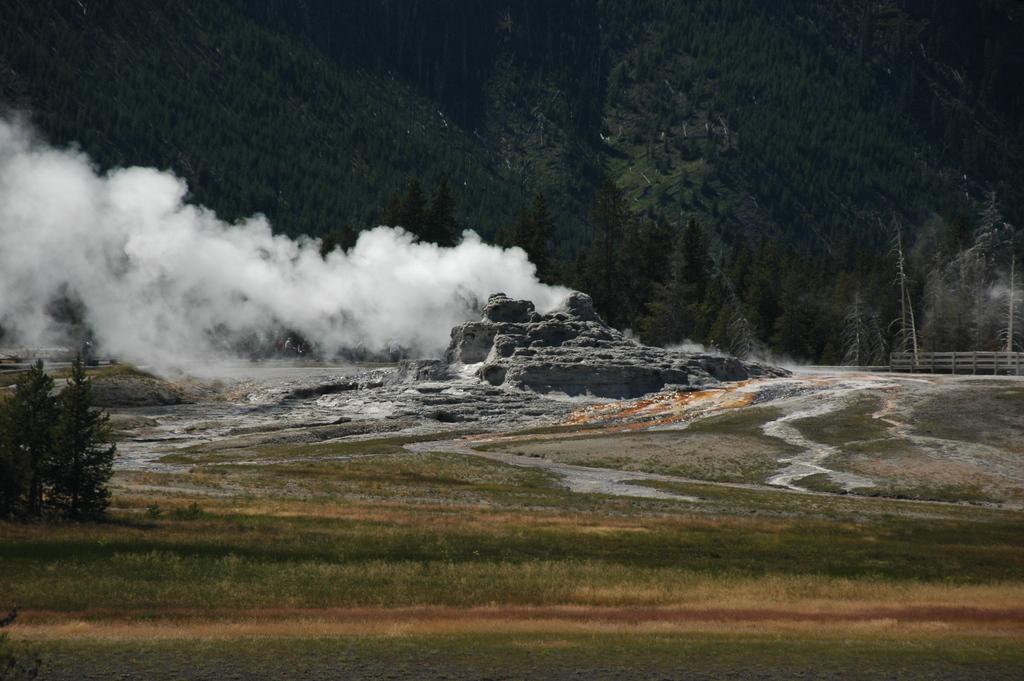In one or two sentences, can you explain what this image depicts? In the image we can see grass, plant, stones, smoke, trees and fence. 